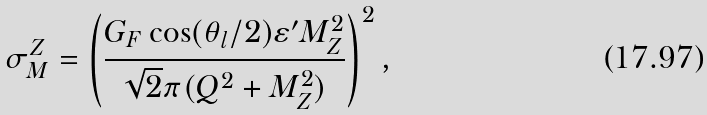Convert formula to latex. <formula><loc_0><loc_0><loc_500><loc_500>\sigma _ { M } ^ { Z } = \left ( \frac { G _ { F } \cos ( \theta _ { l } / 2 ) \varepsilon ^ { \prime } M _ { Z } ^ { 2 } } { \sqrt { 2 } \pi ( Q ^ { 2 } + M _ { Z } ^ { 2 } ) } \right ) ^ { 2 } ,</formula> 